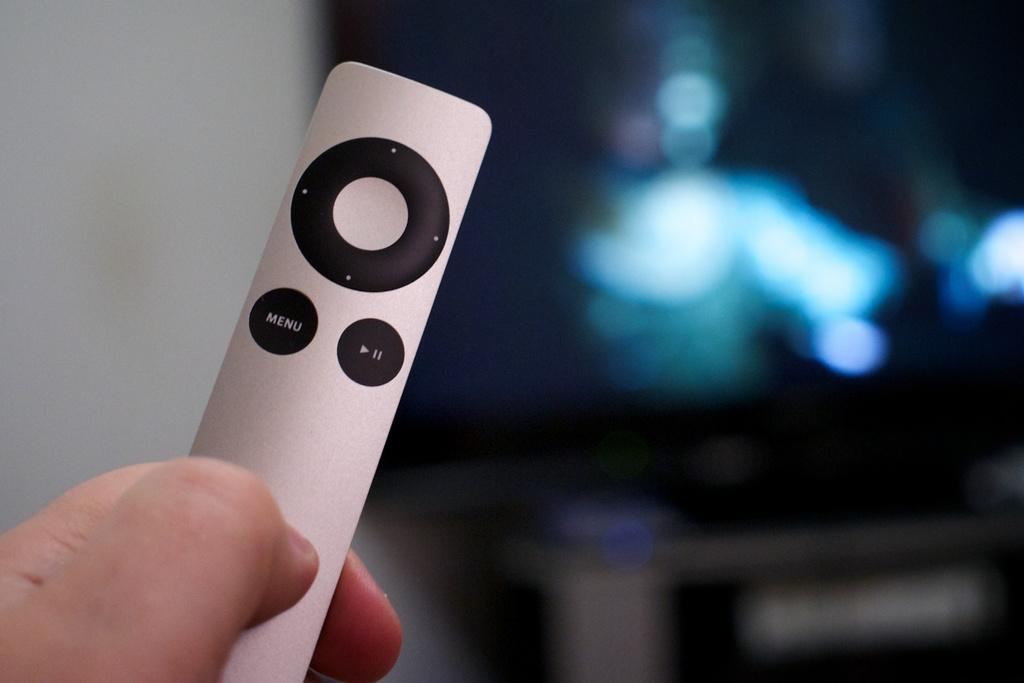<image>
Give a short and clear explanation of the subsequent image. an apple tv remote with a button labelled menu 